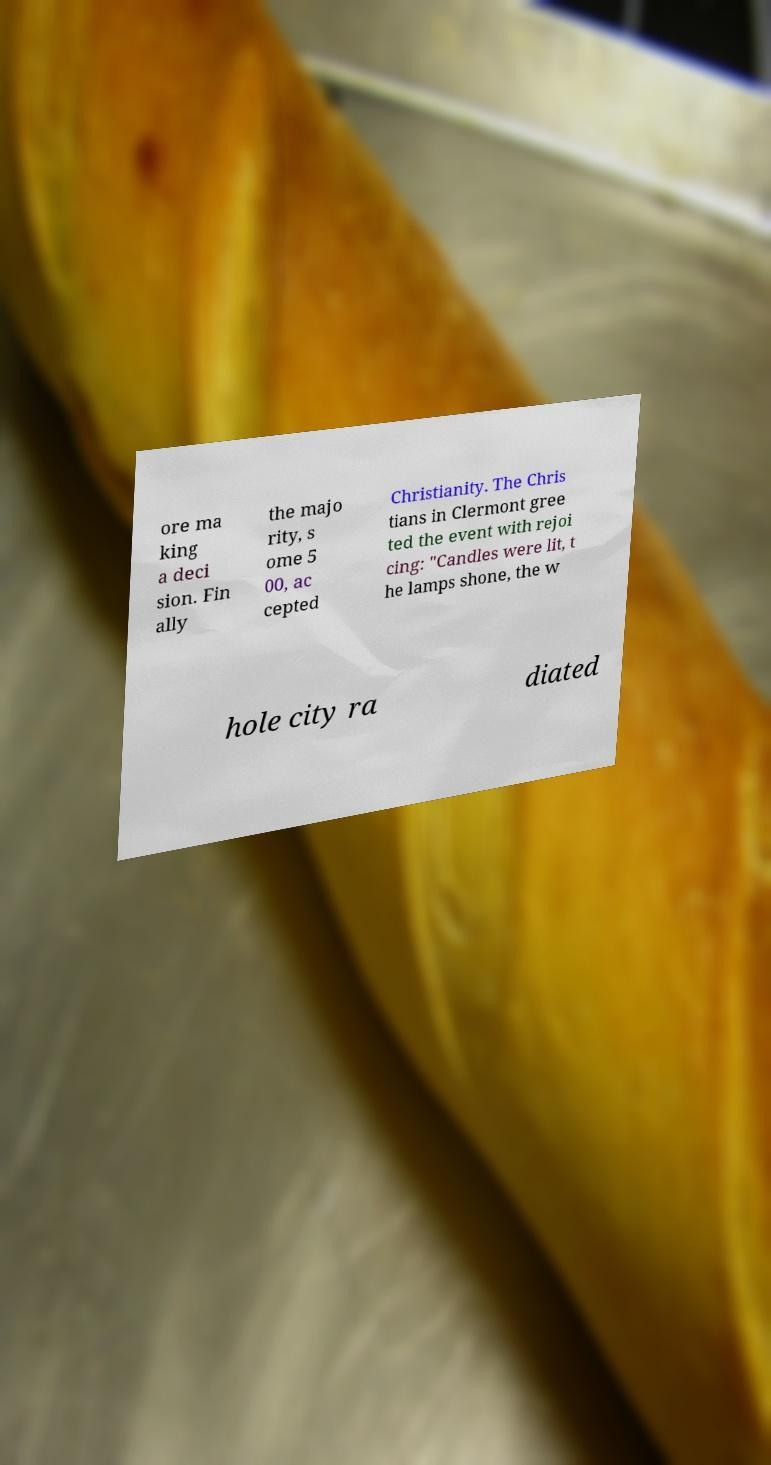Could you assist in decoding the text presented in this image and type it out clearly? ore ma king a deci sion. Fin ally the majo rity, s ome 5 00, ac cepted Christianity. The Chris tians in Clermont gree ted the event with rejoi cing: "Candles were lit, t he lamps shone, the w hole city ra diated 